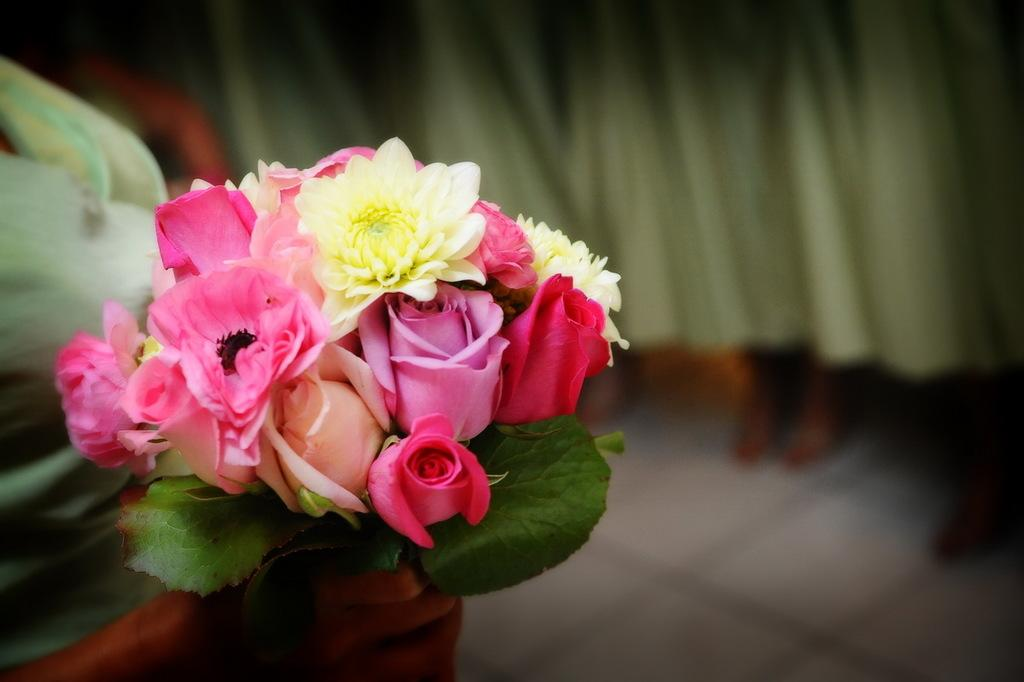What is present in the image? There is a person in the image. What is the person holding? The person is holding flowers. What scent can be detected from the flowers in the image? The image does not provide any information about the scent of the flowers, so it cannot be determined from the image. 